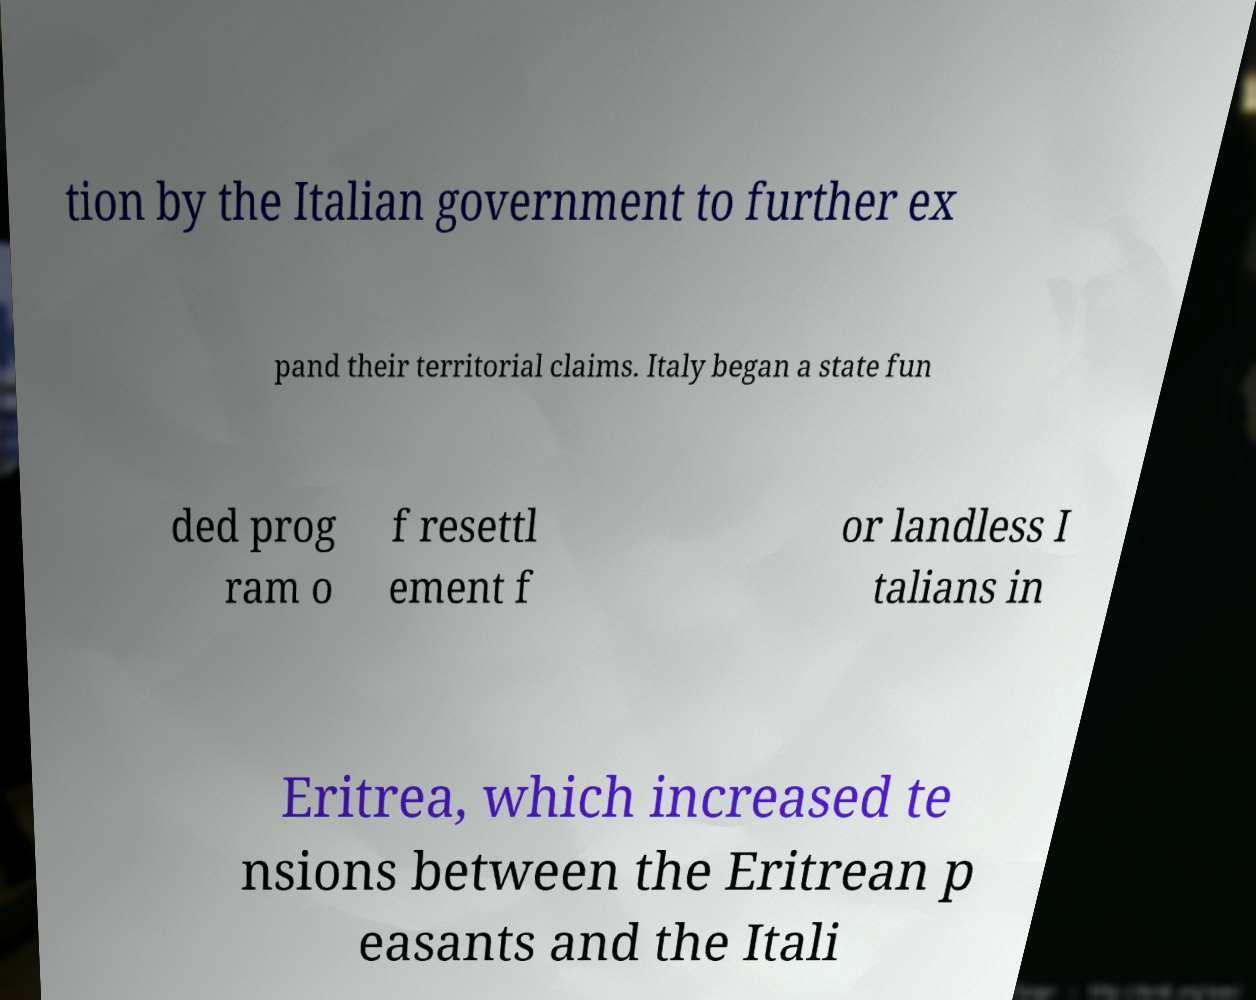Please read and relay the text visible in this image. What does it say? tion by the Italian government to further ex pand their territorial claims. Italy began a state fun ded prog ram o f resettl ement f or landless I talians in Eritrea, which increased te nsions between the Eritrean p easants and the Itali 